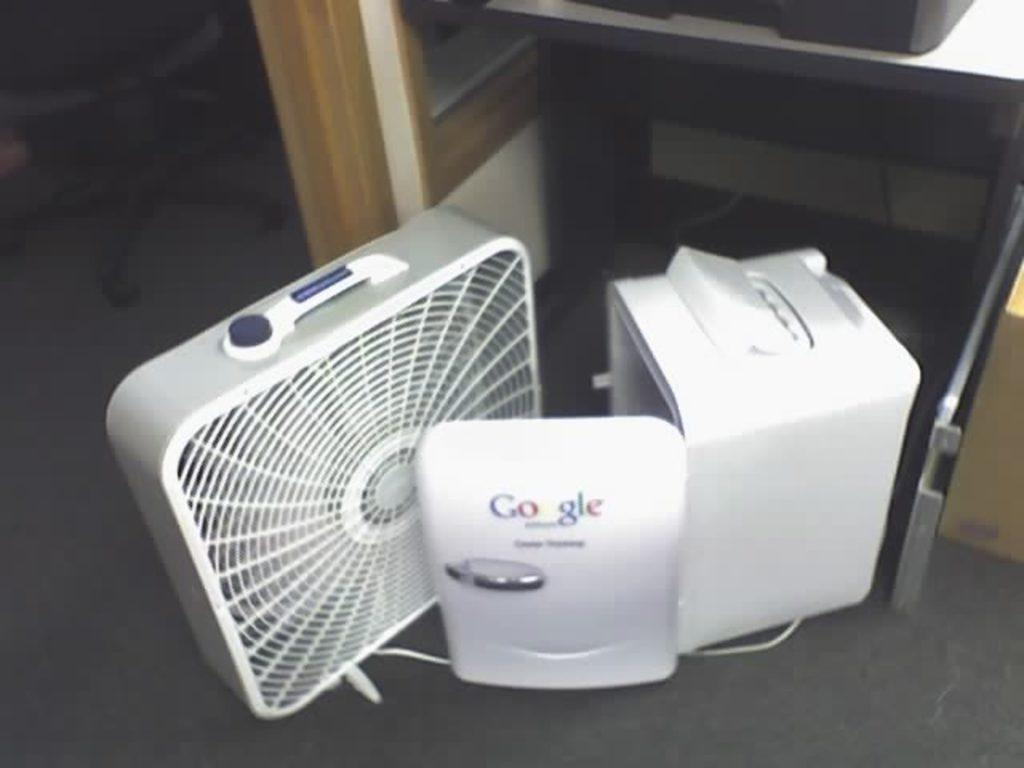What is on the floor in the image? There are objects on the floor in the image. What can be seen in the background of the image? There is a stand in the background of the image. What is on the stand? There is a black object on the stand. Is there any furniture in the image? Yes, there is a chair in the image. How many boys are playing in the park in the image? There is no mention of boys or a park in the image; it only features objects on the floor, a stand with a black object, and a chair. 